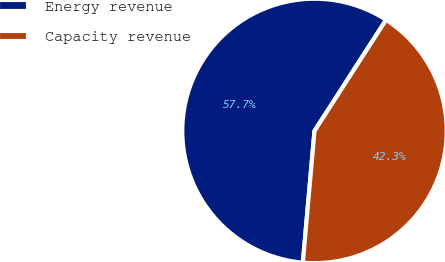Convert chart. <chart><loc_0><loc_0><loc_500><loc_500><pie_chart><fcel>Energy revenue<fcel>Capacity revenue<nl><fcel>57.7%<fcel>42.3%<nl></chart> 